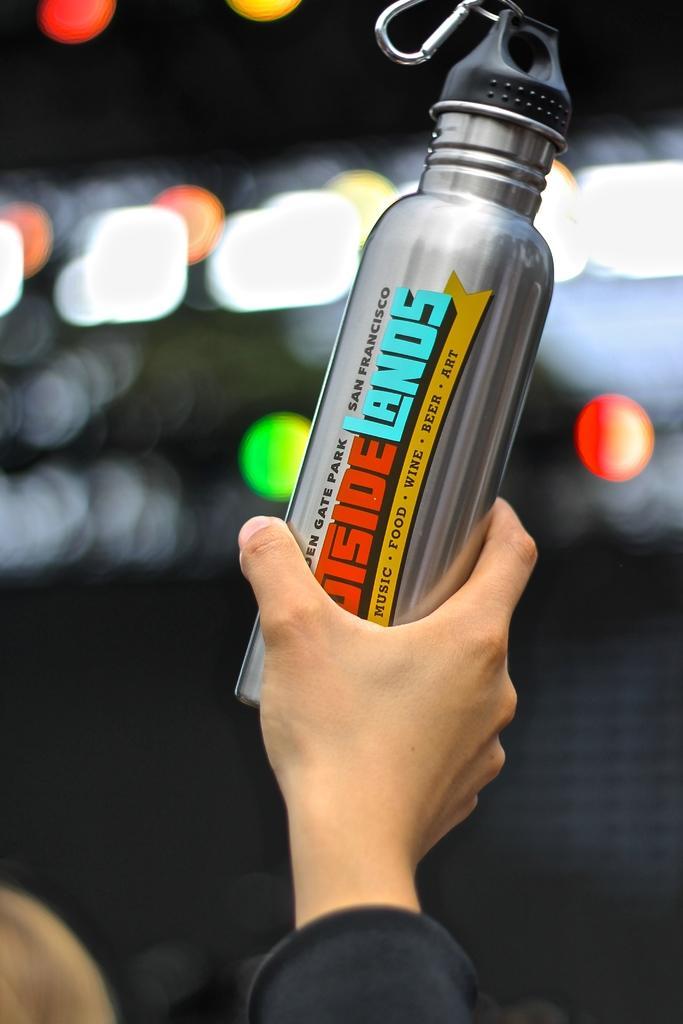Please provide a concise description of this image. In this image we can see the hand of a person holding a metal bottle with some text on it. On the backside we can see some lights. 